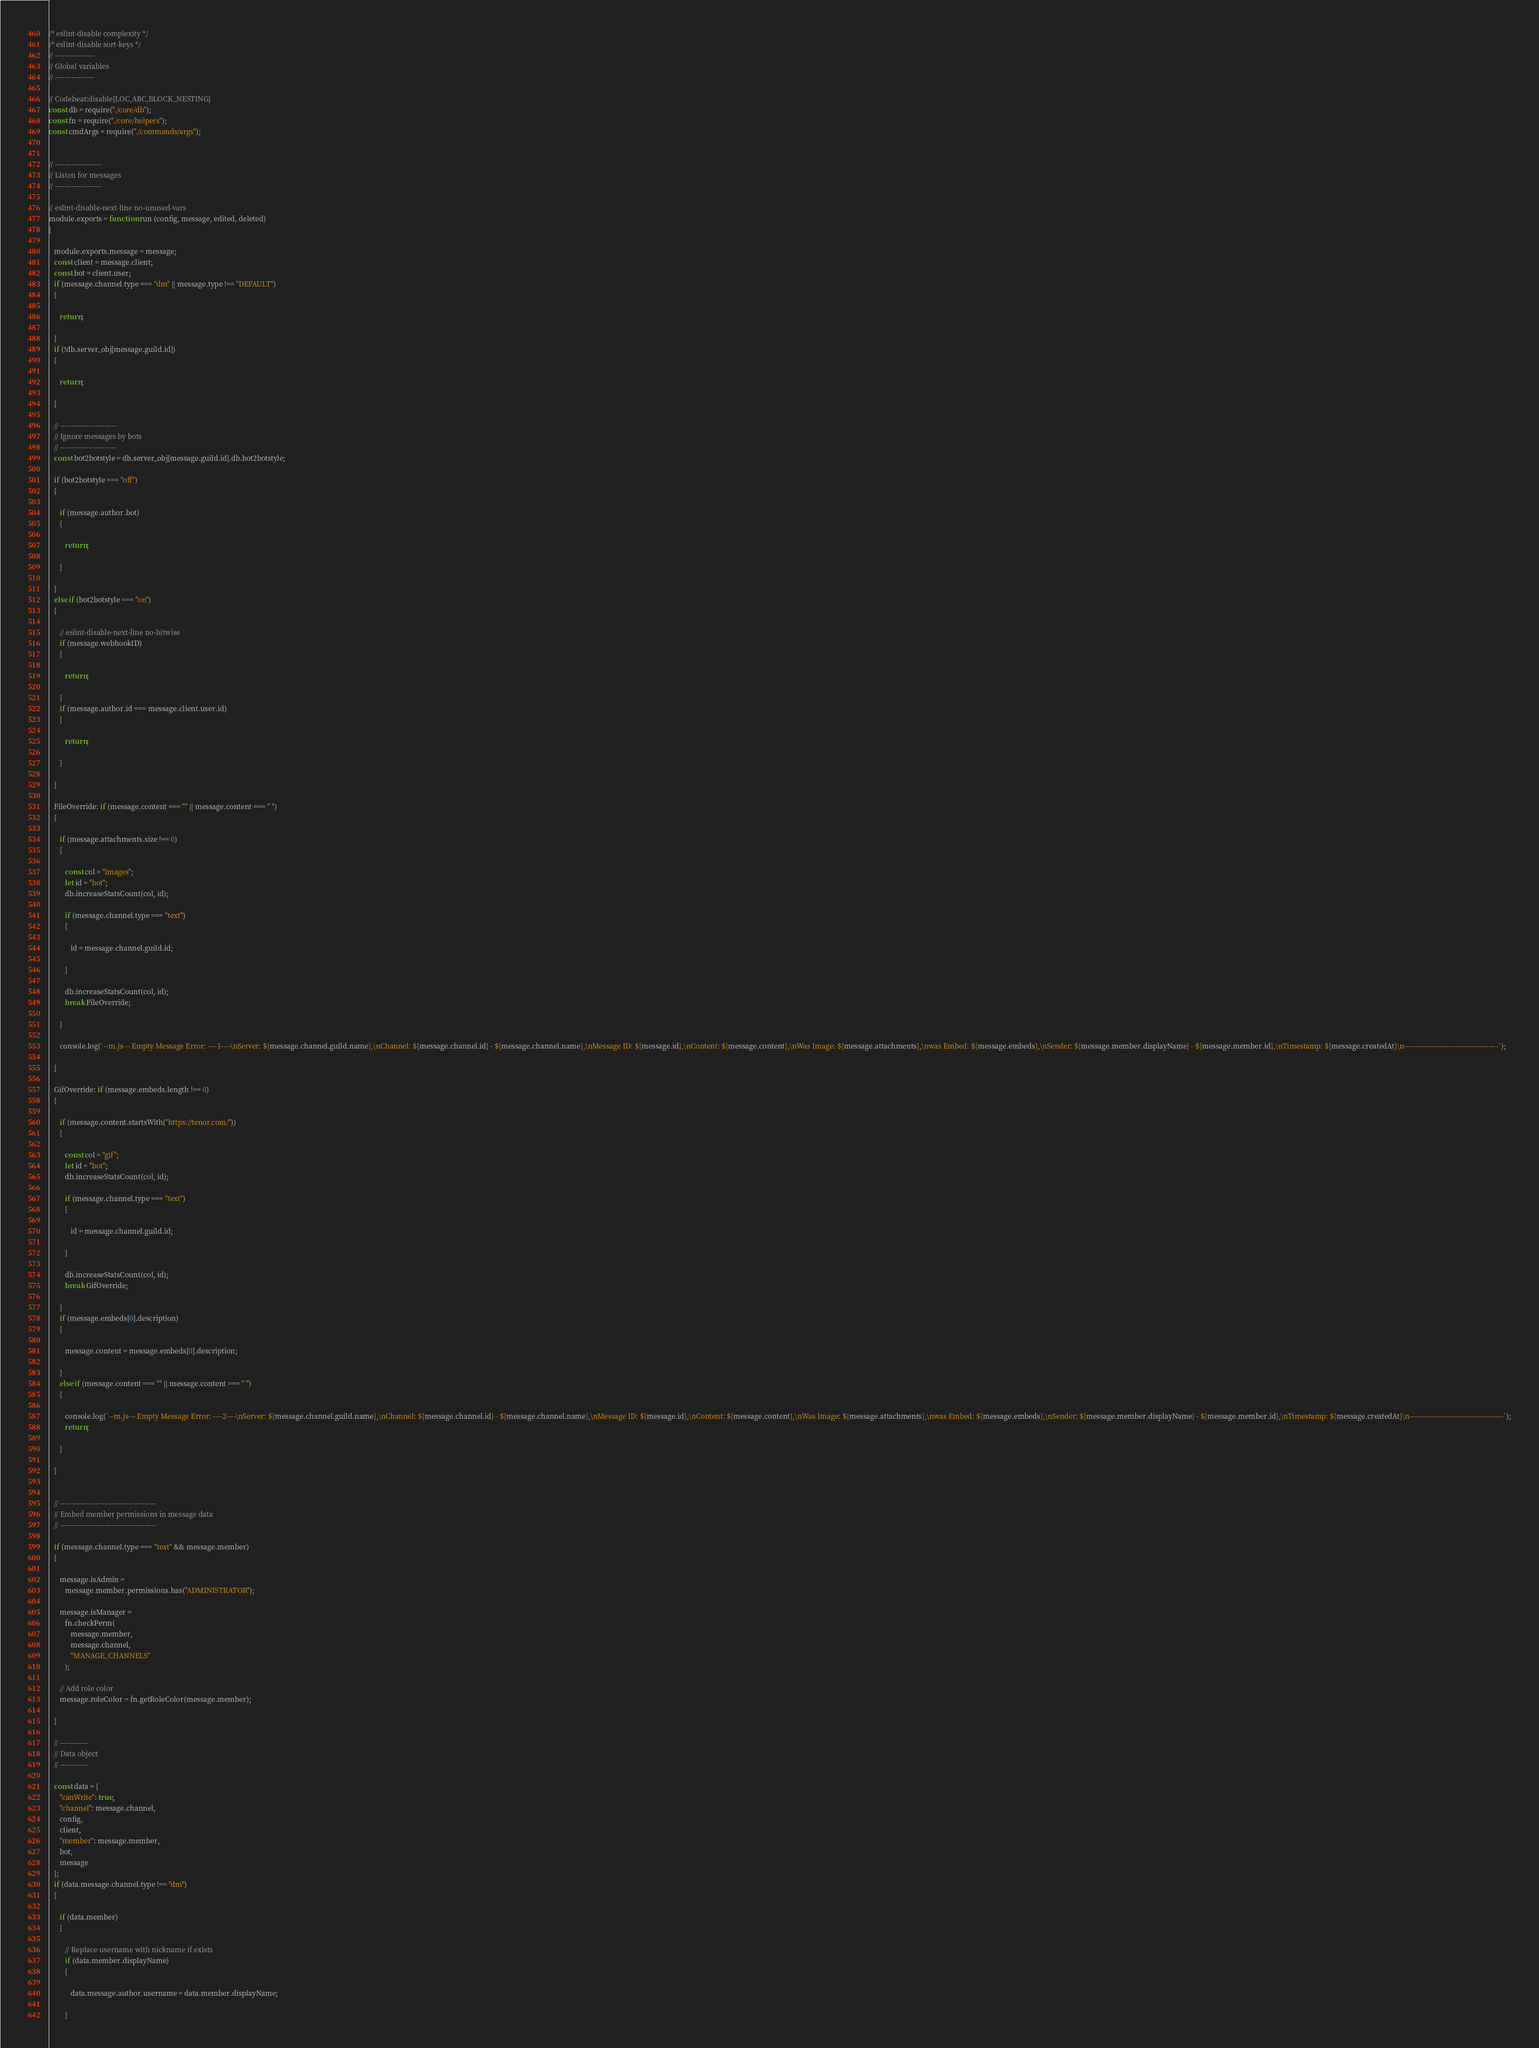Convert code to text. <code><loc_0><loc_0><loc_500><loc_500><_JavaScript_>/* eslint-disable complexity */
/* eslint-disable sort-keys */
// -----------------
// Global variables
// -----------------

// Codebeat:disable[LOC,ABC,BLOCK_NESTING]
const db = require("./core/db");
const fn = require("./core/helpers");
const cmdArgs = require("./commands/args");


// --------------------
// Listen for messages
// --------------------

// eslint-disable-next-line no-unused-vars
module.exports = function run (config, message, edited, deleted)
{

   module.exports.message = message;
   const client = message.client;
   const bot = client.user;
   if (message.channel.type === "dm" || message.type !== "DEFAULT")
   {

      return;

   }
   if (!db.server_obj[message.guild.id])
   {

      return;

   }

   // ------------------------
   // Ignore messages by bots
   // ------------------------
   const bot2botstyle = db.server_obj[message.guild.id].db.bot2botstyle;

   if (bot2botstyle === "off")
   {

      if (message.author.bot)
      {

         return;

      }

   }
   else if (bot2botstyle === "on")
   {

      // eslint-disable-next-line no-bitwise
      if (message.webhookID)
      {

         return;

      }
      if (message.author.id === message.client.user.id)
      {

         return;

      }

   }

   FileOverride: if (message.content === "" || message.content === " ")
   {

      if (message.attachments.size !== 0)
      {

         const col = "images";
         let id = "bot";
         db.increaseStatsCount(col, id);

         if (message.channel.type === "text")
         {

            id = message.channel.guild.id;

         }

         db.increaseStatsCount(col, id);
         break FileOverride;

      }

      console.log(`--m.js--- Empty Message Error: ----1----\nServer: ${message.channel.guild.name},\nChannel: ${message.channel.id} - ${message.channel.name},\nMessage ID: ${message.id},\nContent: ${message.content},\nWas Image: ${message.attachments},\nwas Embed: ${message.embeds},\nSender: ${message.member.displayName} - ${message.member.id},\nTimestamp: ${message.createdAt}\n----------------------------------------`);

   }

   GifOverride: if (message.embeds.length !== 0)
   {

      if (message.content.startsWith("https://tenor.com/"))
      {

         const col = "gif";
         let id = "bot";
         db.increaseStatsCount(col, id);

         if (message.channel.type === "text")
         {

            id = message.channel.guild.id;

         }

         db.increaseStatsCount(col, id);
         break GifOverride;

      }
      if (message.embeds[0].description)
      {

         message.content = message.embeds[0].description;

      }
      else if (message.content === "" || message.content === " ")
      {

         console.log(`--m.js--- Empty Message Error: ----2----\nServer: ${message.channel.guild.name},\nChannel: ${message.channel.id} - ${message.channel.name},\nMessage ID: ${message.id},\nContent: ${message.content},\nWas Image: ${message.attachments},\nwas Embed: ${message.embeds},\nSender: ${message.member.displayName} - ${message.member.id},\nTimestamp: ${message.createdAt}\n----------------------------------------`);
         return;

      }

   }


   // -----------------------------------------
   // Embed member permissions in message data
   // -----------------------------------------

   if (message.channel.type === "text" && message.member)
   {

      message.isAdmin =
         message.member.permissions.has("ADMINISTRATOR");

      message.isManager =
         fn.checkPerm(
            message.member,
            message.channel,
            "MANAGE_CHANNELS"
         );

      // Add role color
      message.roleColor = fn.getRoleColor(message.member);

   }

   // ------------
   // Data object
   // ------------

   const data = {
      "canWrite": true,
      "channel": message.channel,
      config,
      client,
      "member": message.member,
      bot,
      message
   };
   if (data.message.channel.type !== "dm")
   {

      if (data.member)
      {

         // Replace username with nickname if exists
         if (data.member.displayName)
         {

            data.message.author.username = data.member.displayName;

         }
</code> 